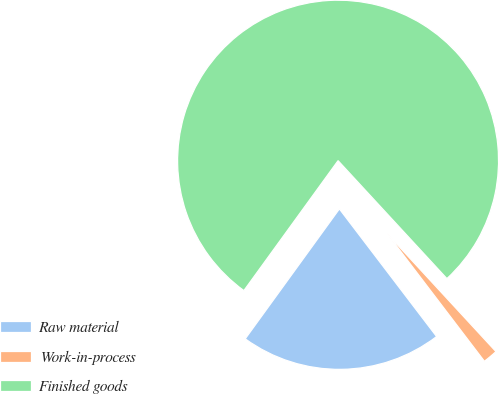Convert chart to OTSL. <chart><loc_0><loc_0><loc_500><loc_500><pie_chart><fcel>Raw material<fcel>Work-in-process<fcel>Finished goods<nl><fcel>20.34%<fcel>1.5%<fcel>78.15%<nl></chart> 